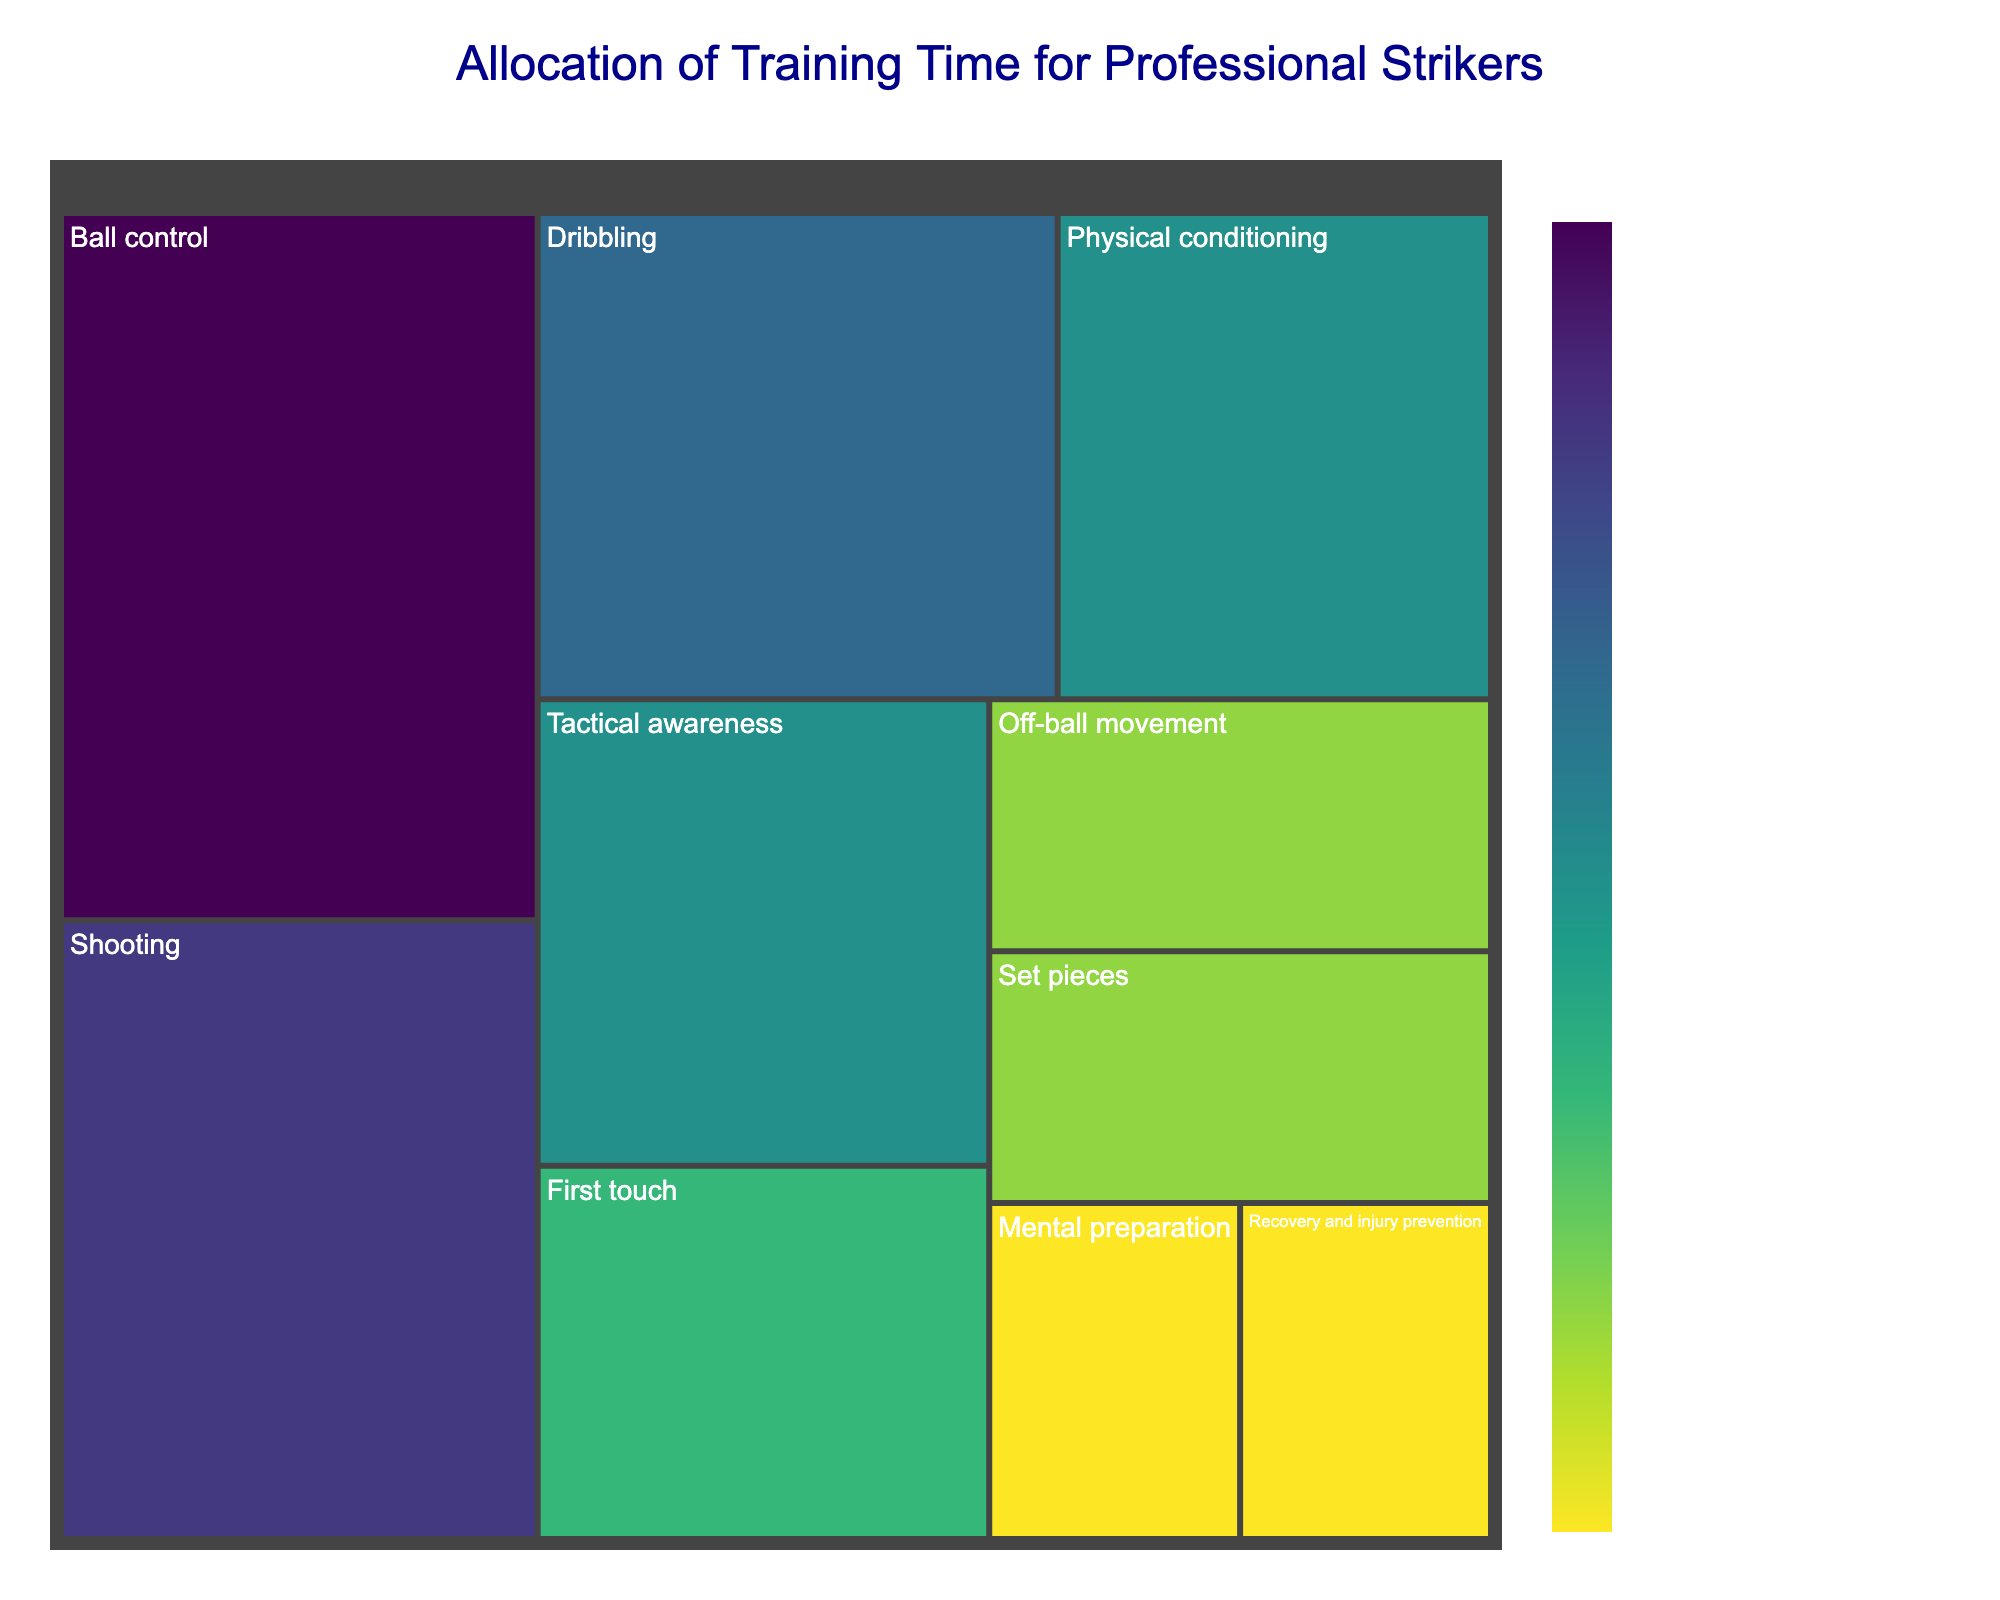What is the title of the treemap? The title is directly displayed at the top of the figure.
Answer: Allocation of Training Time for Professional Strikers Which skill has the highest allocation of training time? Find the largest rectangle in the treemap and check the label. This represents the highest training time allocation.
Answer: Ball control How many hours per week are allocated to "Set pieces"? Look for the "Set pieces" section in the treemap and note the hours indicated.
Answer: 3 hours What is the total time allocated to "Mental preparation" and "Recovery and injury prevention"? Find and read the values for both "Mental preparation" and "Recovery and injury prevention". Add them together. 2 hours + 2 hours = 4 hours.
Answer: 4 hours Which skill has a higher time allocation: "Shooting" or "Tactical awareness"? Compare the areas labeled "Shooting" and "Tactical awareness" by noting their respective hours. "Shooting" has 7 hours and "Tactical awareness" has 5 hours.
Answer: Shooting Is more time allocated to "Physical conditioning" or "First touch"? Compare the areas labeled "Physical conditioning" and "First touch" by noting their respective hours. "Physical conditioning" has 5 hours and "First touch" has 4 hours.
Answer: Physical conditioning What is the difference in training hours between "Ball control" and "Off-ball movement"? Identify the hours allocated to "Ball control" and "Off-ball movement". Subtract the lower value from the higher value. 8 hours - 3 hours = 5 hours.
Answer: 5 hours What skill has the smallest allocation of training time? Find the smallest rectangle in the treemap and check the label. This represents the smallest training time allocation.
Answer: Mental preparation What is the average weekly training time for "Dribbling" and "Shooting"? Find and read the values for "Dribbling" and "Shooting". Add them together and then divide by 2. 6 hours + 7 hours = 13 hours, 13 hours / 2 = 6.5 hours.
Answer: 6.5 hours How does the time allocated to "Tactical awareness" compare to "Recovery and injury prevention"? Find and compare the hours for "Tactical awareness" and "Recovery and injury prevention". 5 hours for "Tactical awareness" and 2 hours for "Recovery and injury prevention" shows that "Tactical awareness" is greater.
Answer: Tactical awareness is more 